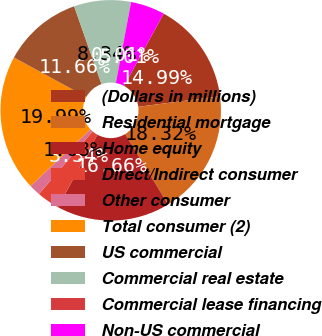Convert chart to OTSL. <chart><loc_0><loc_0><loc_500><loc_500><pie_chart><fcel>(Dollars in millions)<fcel>Residential mortgage<fcel>Home equity<fcel>Direct/Indirect consumer<fcel>Other consumer<fcel>Total consumer (2)<fcel>US commercial<fcel>Commercial real estate<fcel>Commercial lease financing<fcel>Non-US commercial<nl><fcel>14.99%<fcel>18.32%<fcel>16.66%<fcel>3.34%<fcel>1.68%<fcel>19.99%<fcel>11.66%<fcel>8.34%<fcel>0.01%<fcel>5.01%<nl></chart> 